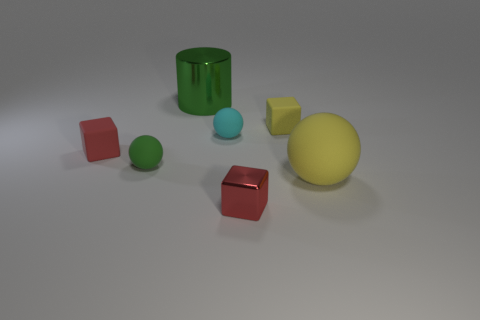Subtract all red blocks. How many blocks are left? 1 Subtract 1 blocks. How many blocks are left? 2 Subtract all cyan cylinders. How many red cubes are left? 2 Add 1 green matte objects. How many objects exist? 8 Subtract all brown balls. Subtract all yellow cubes. How many balls are left? 3 Subtract all blocks. How many objects are left? 4 Subtract all large cyan cubes. Subtract all red metallic things. How many objects are left? 6 Add 1 small spheres. How many small spheres are left? 3 Add 7 green matte objects. How many green matte objects exist? 8 Subtract 0 purple blocks. How many objects are left? 7 